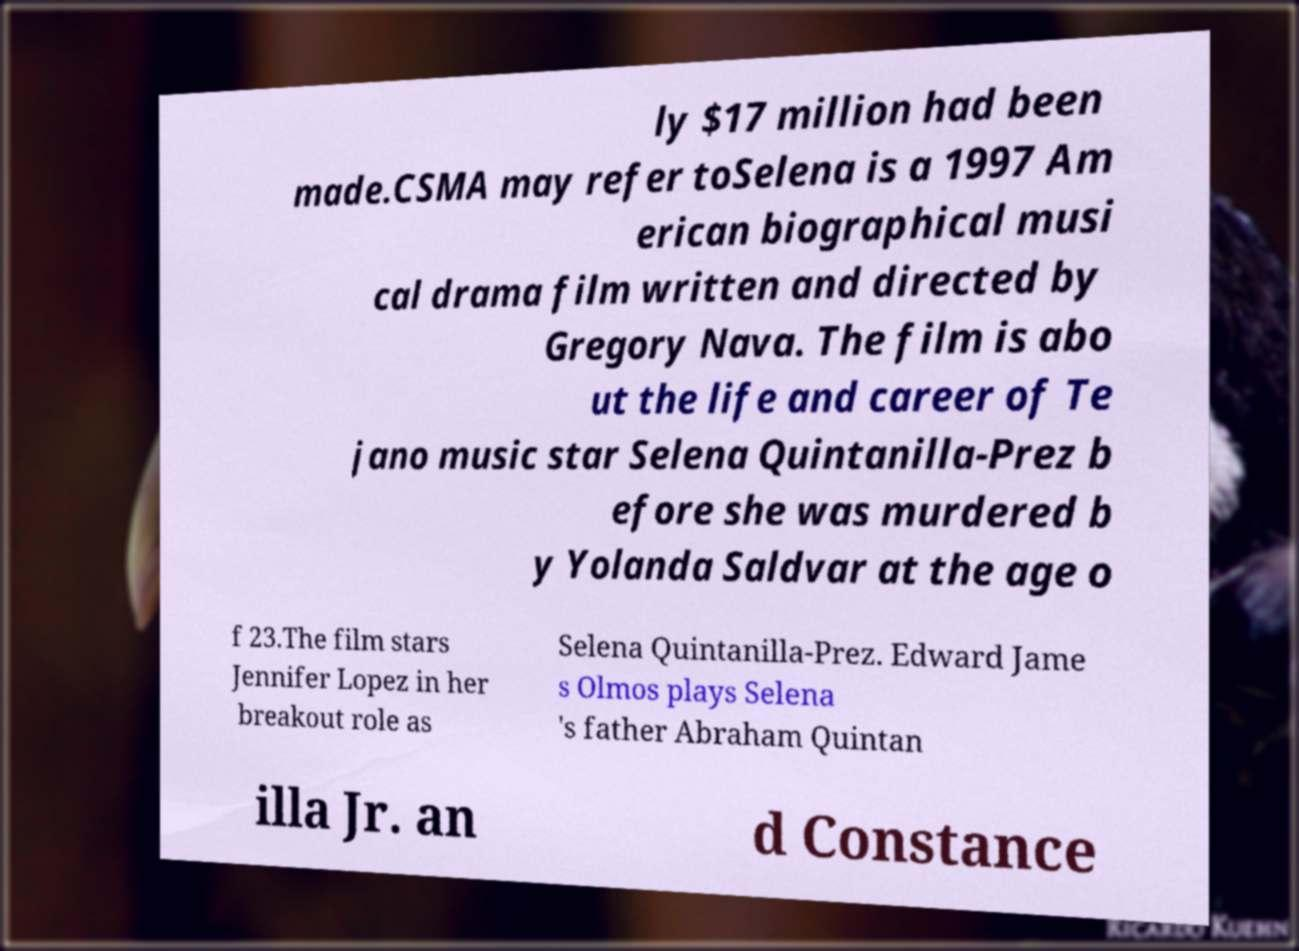Could you extract and type out the text from this image? ly $17 million had been made.CSMA may refer toSelena is a 1997 Am erican biographical musi cal drama film written and directed by Gregory Nava. The film is abo ut the life and career of Te jano music star Selena Quintanilla-Prez b efore she was murdered b y Yolanda Saldvar at the age o f 23.The film stars Jennifer Lopez in her breakout role as Selena Quintanilla-Prez. Edward Jame s Olmos plays Selena 's father Abraham Quintan illa Jr. an d Constance 